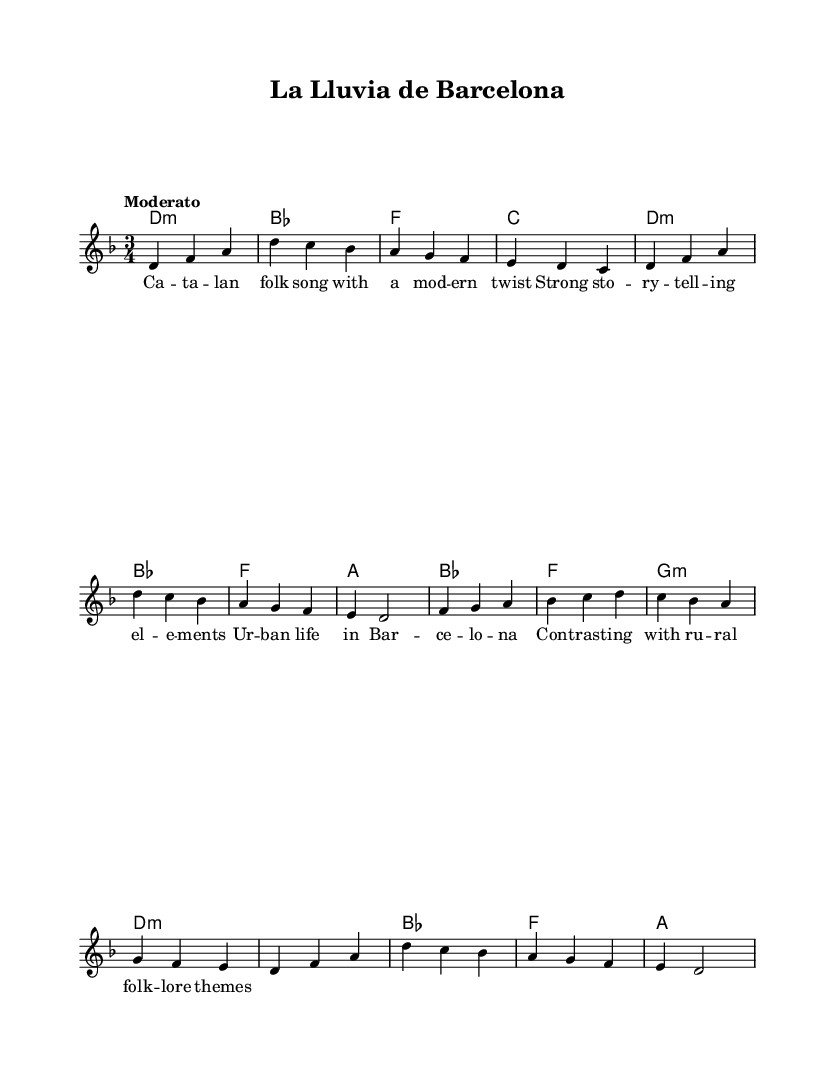What is the key signature of this music? The key signature is D minor, which can be identified by looking for a single flat, indicating the note C is lowered. In the music, we see the key marked as "D", with flats noted in the chords.
Answer: D minor What is the time signature of this piece? The time signature is 3/4, which is shown at the beginning of the score as a fraction with a 3 on top and a 4 on the bottom. This indicates that there are three beats in each measure and that the quarter note gets the beat.
Answer: 3/4 What is the tempo of "La Lluvia de Barcelona"? The tempo marking is "Moderato", which suggests a moderate speed for the performance. This is written alongside the time signature at the beginning of the score.
Answer: Moderato How many measures does the melody contain? By counting the individual measures in the melody line, we find there are eight measures present. Each section is separated by vertical lines indicating the end of a measure.
Answer: Eight What themes are contrasted in the lyrics? The lyrics discuss urban life in Barcelona contrasted with rural folk lore themes. This is specifically noted in the lyrics, which highlight the dialogue between the two environments.
Answer: Urban vs. rural What music genre does "La Lluvia de Barcelona" represent? This piece represents a modern interpretation of Catalan folk music, as evidenced by the blend of traditional elements with contemporary storytelling and themes.
Answer: Catalan folk music 